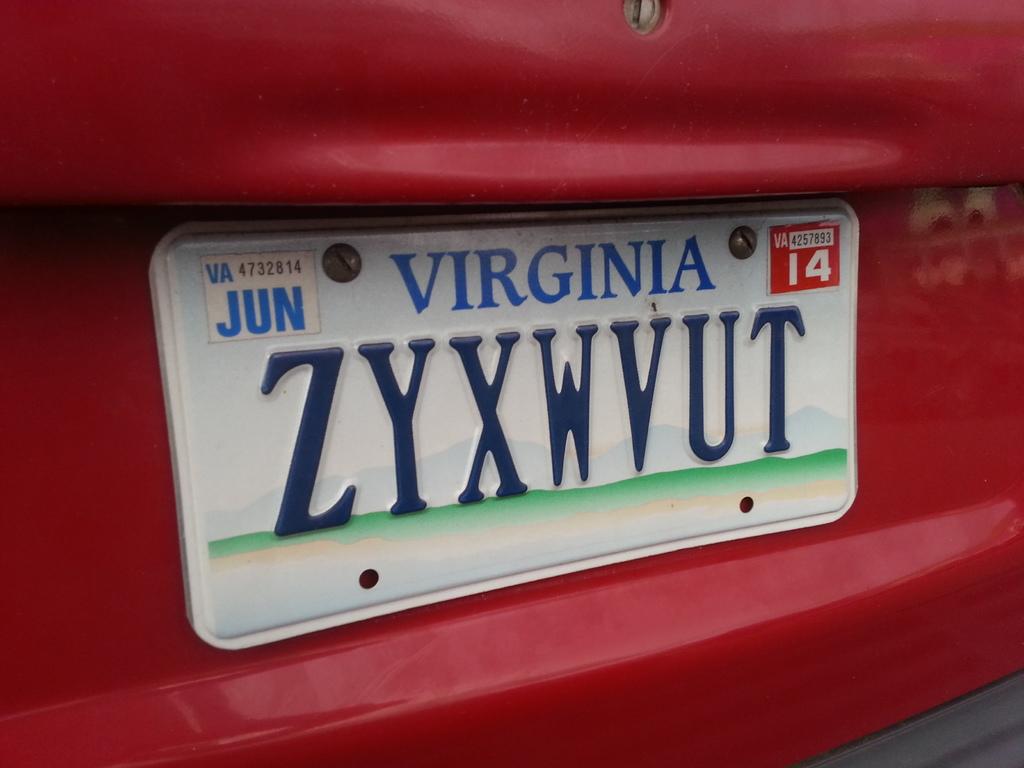What number is the license plate?
Your answer should be compact. Zyxwvut. 